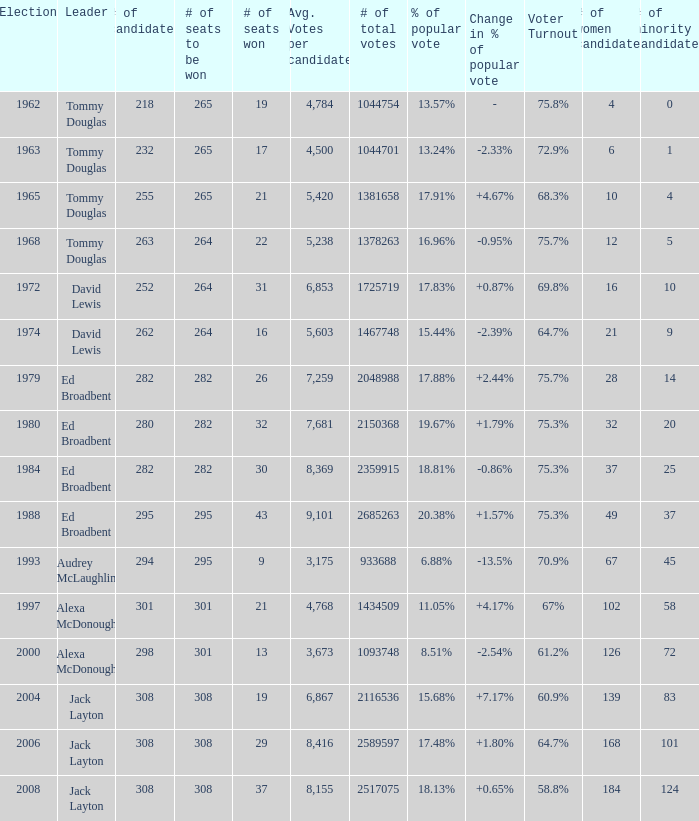Name the number of leaders for % of popular vote being 11.05% 1.0. I'm looking to parse the entire table for insights. Could you assist me with that? {'header': ['Election', 'Leader', '# of candidates', '# of seats to be won', '# of seats won', 'Avg. Votes per candidate', '# of total votes', '% of popular vote', 'Change in % of popular vote', 'Voter Turnout', '# of women candidates', '# of minority candidates'], 'rows': [['1962', 'Tommy Douglas', '218', '265', '19', '4,784', '1044754', '13.57%', '-', '75.8%', '4', '0'], ['1963', 'Tommy Douglas', '232', '265', '17', '4,500', '1044701', '13.24%', '-2.33%', '72.9%', '6', '1'], ['1965', 'Tommy Douglas', '255', '265', '21', '5,420', '1381658', '17.91%', '+4.67%', '68.3%', '10', '4'], ['1968', 'Tommy Douglas', '263', '264', '22', '5,238', '1378263', '16.96%', '-0.95%', '75.7%', '12', '5'], ['1972', 'David Lewis', '252', '264', '31', '6,853', '1725719', '17.83%', '+0.87%', '69.8%', '16', '10'], ['1974', 'David Lewis', '262', '264', '16', '5,603', '1467748', '15.44%', '-2.39%', '64.7%', '21', '9'], ['1979', 'Ed Broadbent', '282', '282', '26', '7,259', '2048988', '17.88%', '+2.44%', '75.7%', '28', '14'], ['1980', 'Ed Broadbent', '280', '282', '32', '7,681', '2150368', '19.67%', '+1.79%', '75.3%', '32', '20'], ['1984', 'Ed Broadbent', '282', '282', '30', '8,369', '2359915', '18.81%', '-0.86%', '75.3%', '37', '25'], ['1988', 'Ed Broadbent', '295', '295', '43', '9,101', '2685263', '20.38%', '+1.57%', '75.3%', '49', '37'], ['1993', 'Audrey McLaughlin', '294', '295', '9', '3,175', '933688', '6.88%', '-13.5%', '70.9%', '67', '45'], ['1997', 'Alexa McDonough', '301', '301', '21', '4,768', '1434509', '11.05%', '+4.17%', '67%', '102', '58'], ['2000', 'Alexa McDonough', '298', '301', '13', '3,673', '1093748', '8.51%', '-2.54%', '61.2%', '126', '72'], ['2004', 'Jack Layton', '308', '308', '19', '6,867', '2116536', '15.68%', '+7.17%', '60.9%', '139', '83'], ['2006', 'Jack Layton', '308', '308', '29', '8,416', '2589597', '17.48%', '+1.80%', '64.7%', '168', '101'], ['2008', 'Jack Layton', '308', '308', '37', '8,155', '2517075', '18.13%', '+0.65%', '58.8%', '184', '124']]} 